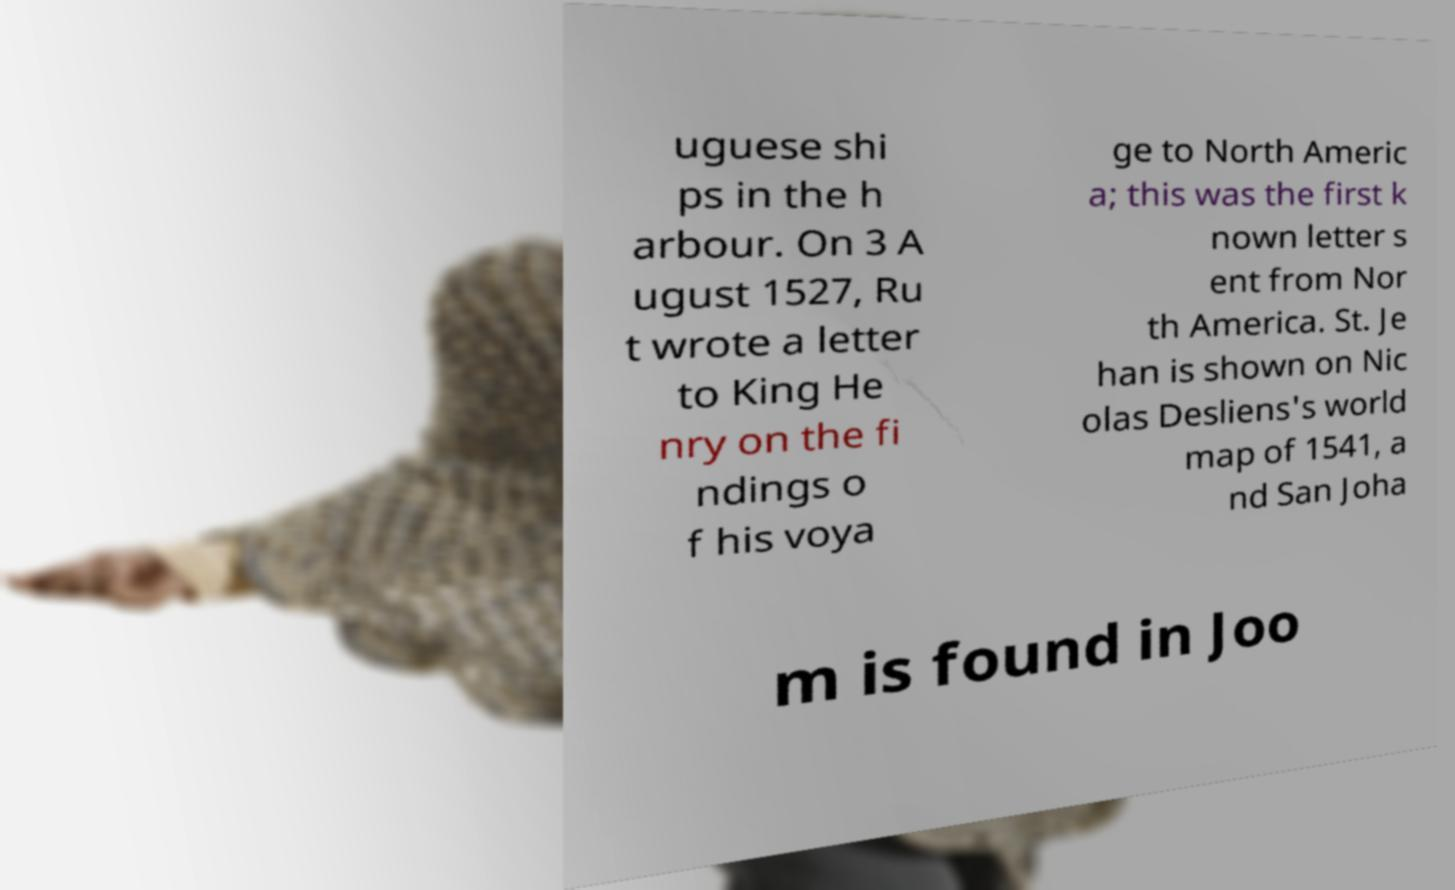Can you accurately transcribe the text from the provided image for me? uguese shi ps in the h arbour. On 3 A ugust 1527, Ru t wrote a letter to King He nry on the fi ndings o f his voya ge to North Americ a; this was the first k nown letter s ent from Nor th America. St. Je han is shown on Nic olas Desliens's world map of 1541, a nd San Joha m is found in Joo 